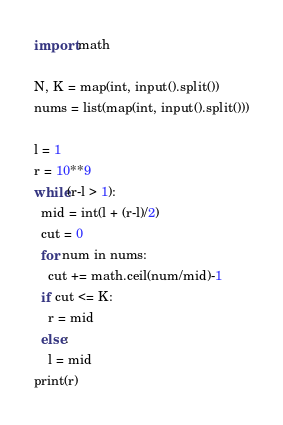Convert code to text. <code><loc_0><loc_0><loc_500><loc_500><_Python_>import math

N, K = map(int, input().split())
nums = list(map(int, input().split()))

l = 1
r = 10**9
while(r-l > 1):
  mid = int(l + (r-l)/2)
  cut = 0
  for num in nums:
    cut += math.ceil(num/mid)-1
  if cut <= K:
    r = mid
  else:
    l = mid
print(r)</code> 